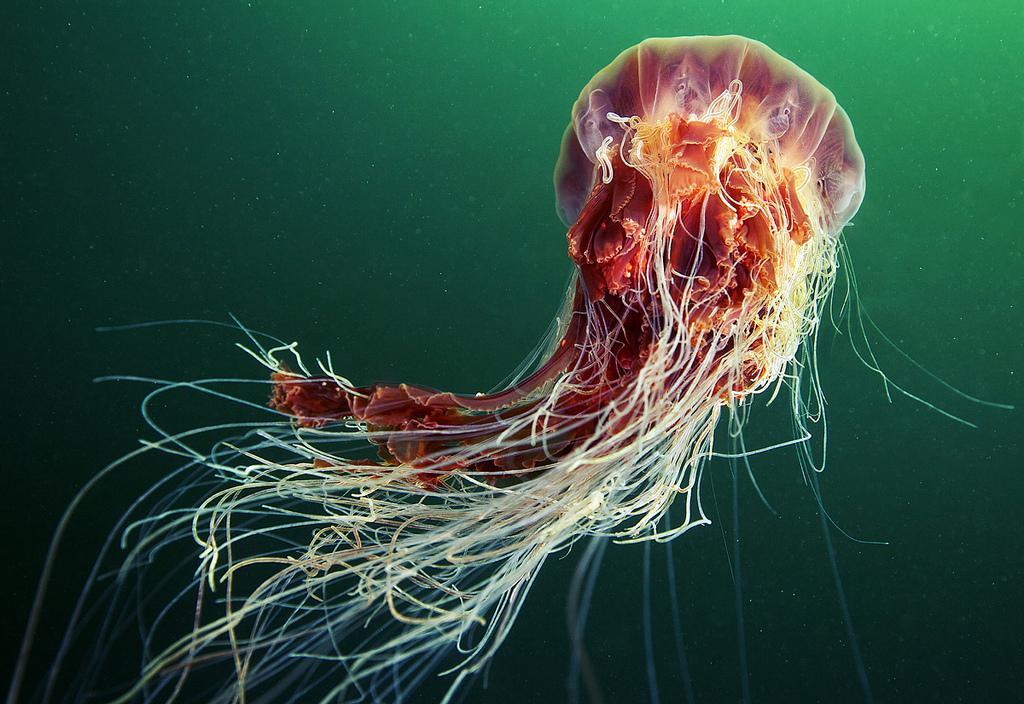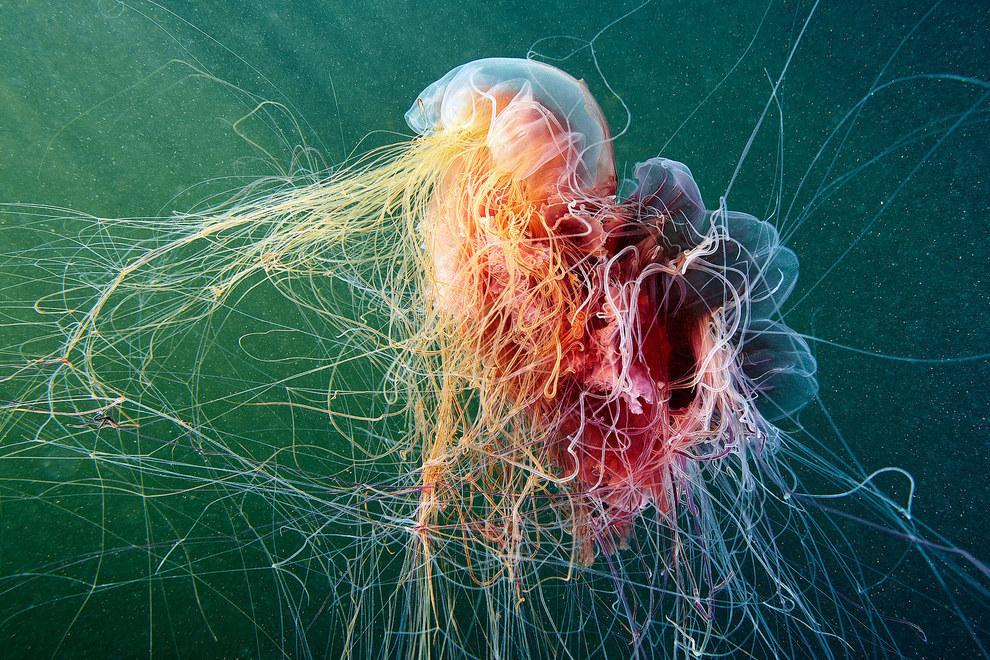The first image is the image on the left, the second image is the image on the right. Assess this claim about the two images: "In at least one of the images, there is greenish light coming through the water above the jellyfish.". Correct or not? Answer yes or no. Yes. The first image is the image on the left, the second image is the image on the right. For the images displayed, is the sentence "Each image includes a jellyfish with multiple threadlike tentacles, and each jellyfish image has a blue-green multi-tone background." factually correct? Answer yes or no. Yes. 